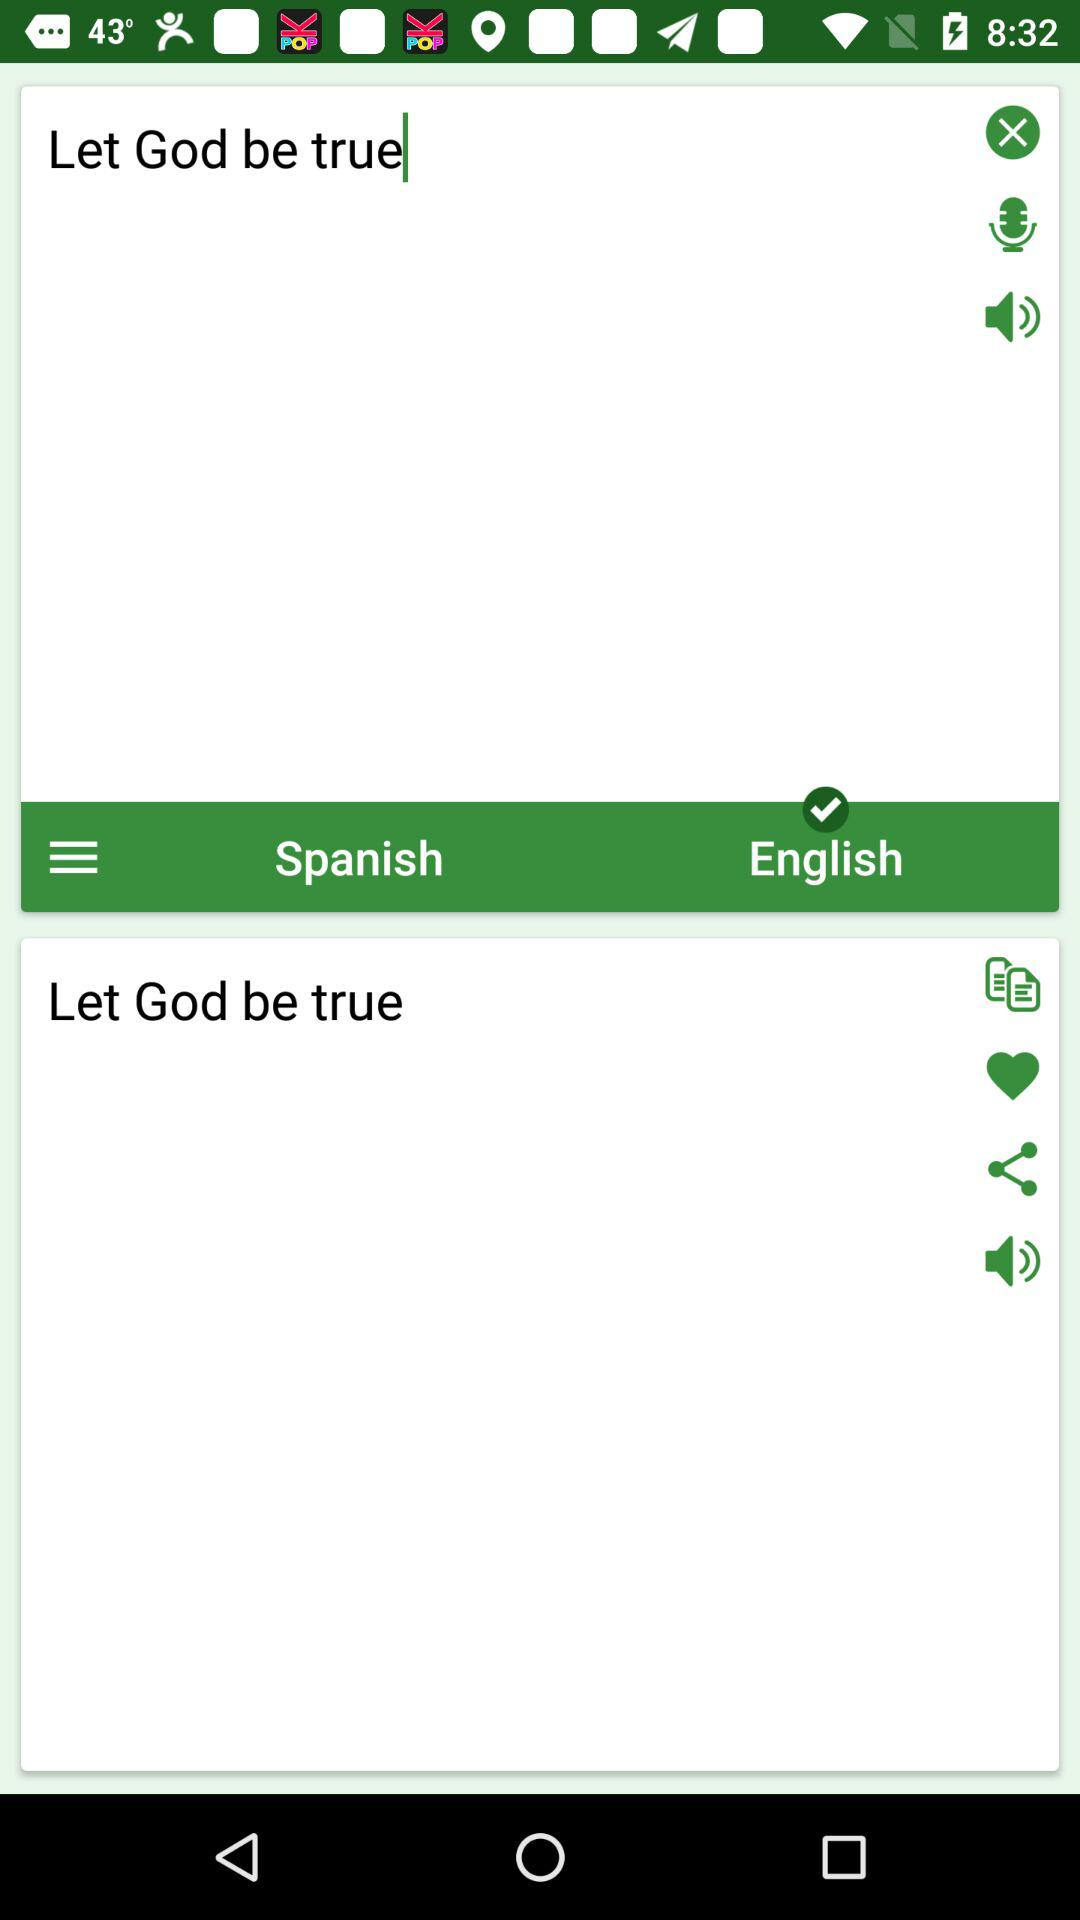What languages are there to translate? There are "Spanish" and "English" languages. 